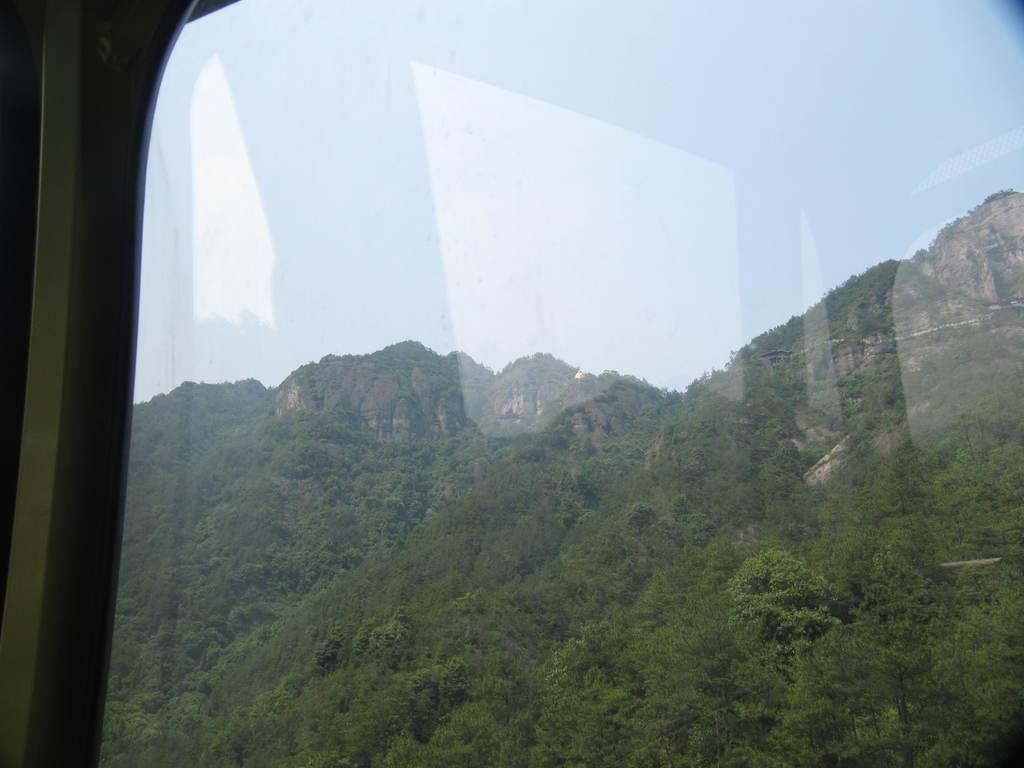What is the medium through which the image is viewed? The image is viewed through a glass. What type of natural landform can be seen in the image? There are mountains visible in the image. What type of vegetation is present in the image? There are trees in the image. What part of the natural environment is visible in the image? The sky is visible in the image. Where is the bean located in the image? There is no bean present in the image. What type of tool is used to rake the trees in the image? There is no tool or action of raking the trees in the image; the trees are stationary. Can you tell me how many faucets are visible in the image? There are no faucets present in the image. 